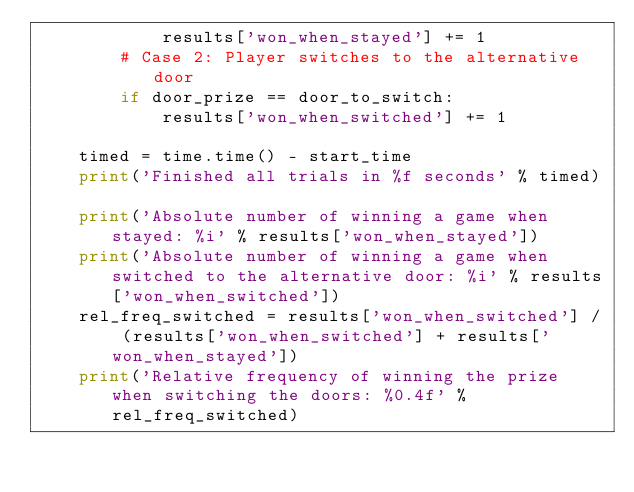<code> <loc_0><loc_0><loc_500><loc_500><_Python_>            results['won_when_stayed'] += 1
        # Case 2: Player switches to the alternative door
        if door_prize == door_to_switch:
            results['won_when_switched'] += 1

    timed = time.time() - start_time
    print('Finished all trials in %f seconds' % timed)

    print('Absolute number of winning a game when stayed: %i' % results['won_when_stayed'])
    print('Absolute number of winning a game when switched to the alternative door: %i' % results['won_when_switched'])
    rel_freq_switched = results['won_when_switched'] / (results['won_when_switched'] + results['won_when_stayed'])
    print('Relative frequency of winning the prize when switching the doors: %0.4f' % rel_freq_switched)</code> 